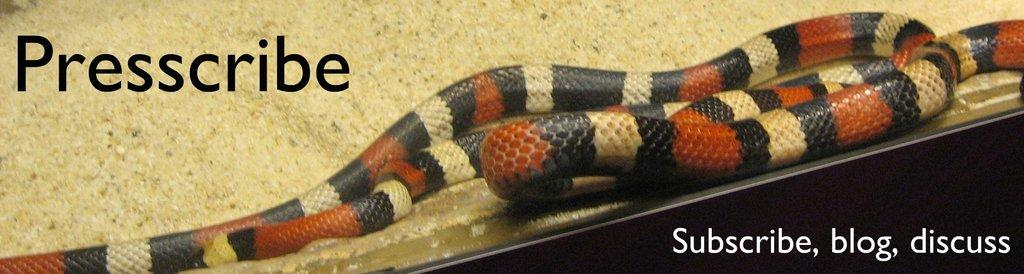What animal is present in the image? There is a snake in the image. Where is the snake located? The snake is on a surface in the image. Is there any text present in the image? Yes, there is text written on the image. What type of grain is being harvested in the image? There is no grain present in the image; it features a snake on a surface with text. 